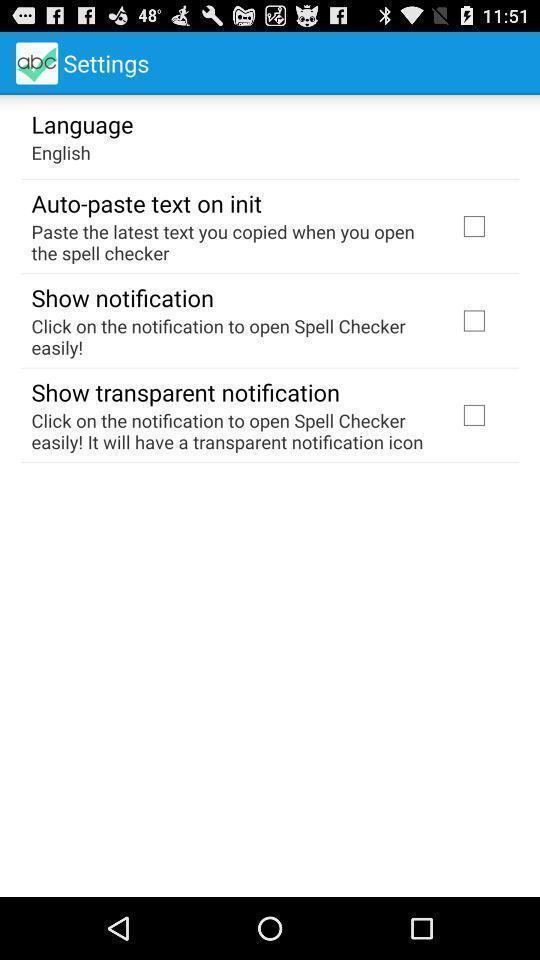What details can you identify in this image? Settings page. 